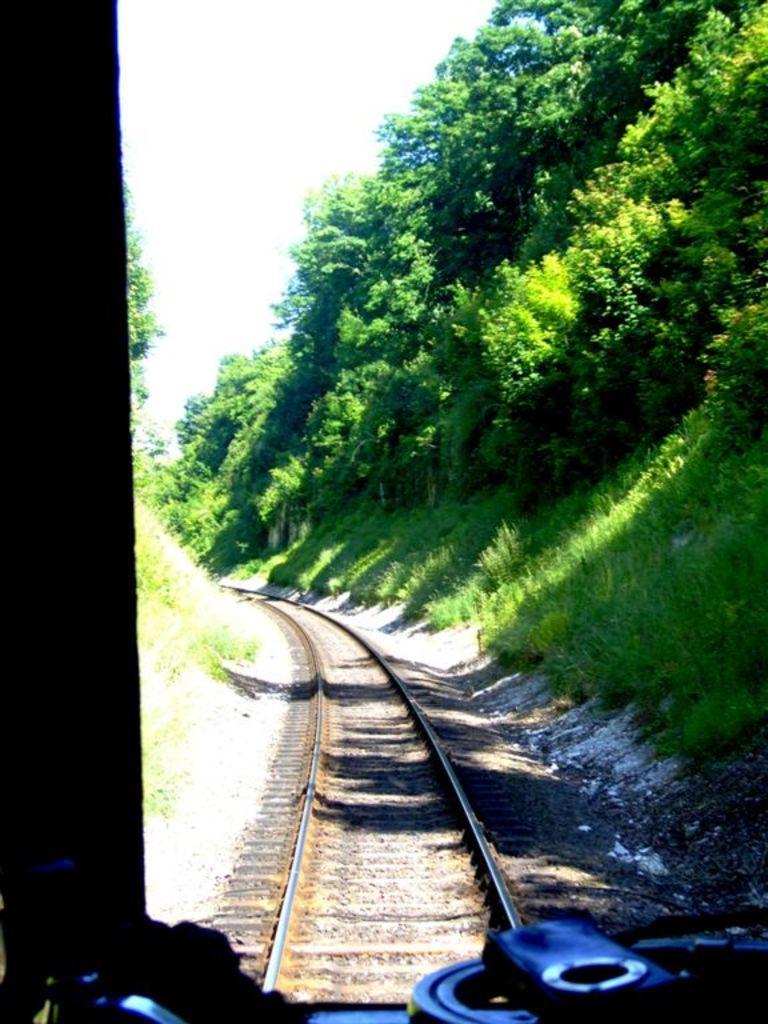Please provide a concise description of this image. In this image I can see the track. To the side of the track there are many trees. And I can see some objects in the front. In the background there is a white sky. 